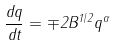Convert formula to latex. <formula><loc_0><loc_0><loc_500><loc_500>\frac { d q } { d t } = \mp 2 B ^ { 1 / 2 } q ^ { \alpha }</formula> 